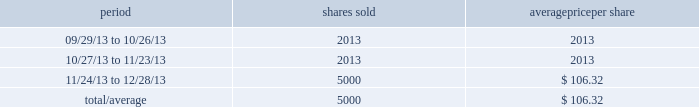Other purchases or sales of equity securities the following chart discloses information regarding shares of snap-on 2019s common stock that were sold by citibank , n.a .
( 201ccitibank 201d ) during the fourth quarter of 2013 pursuant to a prepaid equity forward transaction agreement ( the 201cagreement 201d ) with citibank that is intended to reduce the impact of market risk associated with the stock-based portion of the company 2019s deferred compensation plans .
The company 2019s stock-based deferred compensation liabilities , which are impacted by changes in the company 2019s stock price , increase as the company 2019s stock price rises and decrease as the company 2019s stock price declines .
Pursuant to the agreement , citibank may purchase or sell shares of the company 2019s common stock ( for citibank 2019s account ) in the market or in privately negotiated transactions .
The agreement has no stated expiration date , but the parties expect that each transaction under the agreement will have a term of approximately one year .
The agreement does not provide for snap-on to purchase or repurchase shares .
The following chart discloses information regarding citibank 2019s sales of snap-on common stock during the fourth quarter of 2013 pursuant to the agreement : period shares sold average per share .
2013 annual report 23 .
How is the cash flow statement from financing activities affected by the sales of commons stock during the 4th quarter of 2013? 
Computations: (5000 * 106.32)
Answer: 531600.0. 